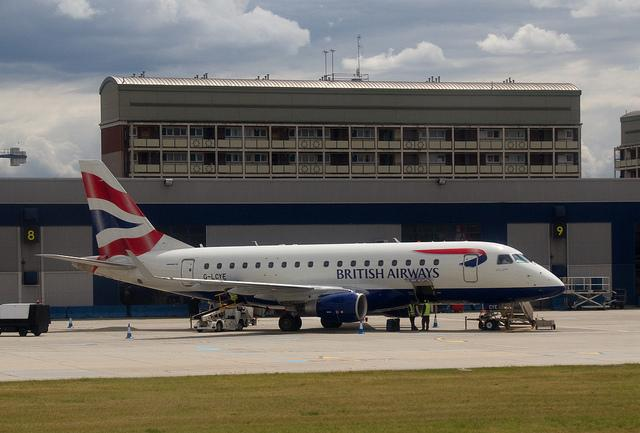What actress was born in the country where the plane comes from? Please explain your reasoning. kate beckinsale. The actress is kate. 